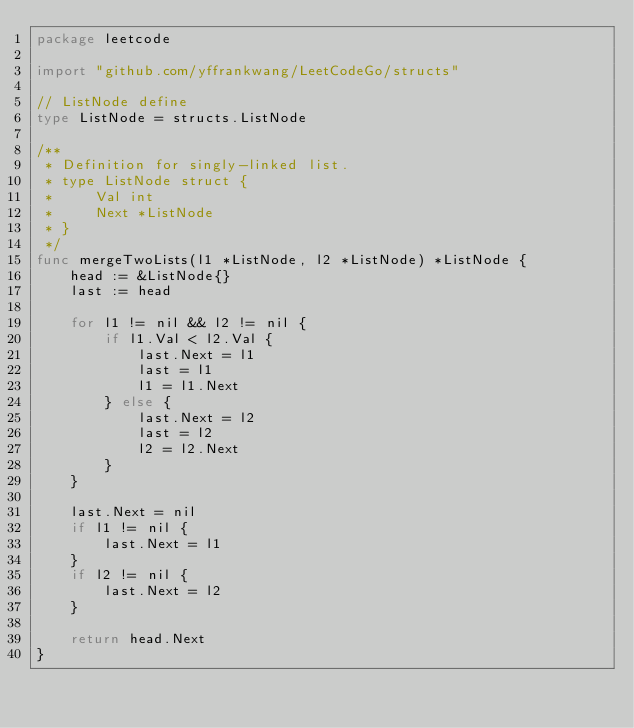<code> <loc_0><loc_0><loc_500><loc_500><_Go_>package leetcode

import "github.com/yffrankwang/LeetCodeGo/structs"

// ListNode define
type ListNode = structs.ListNode

/**
 * Definition for singly-linked list.
 * type ListNode struct {
 *     Val int
 *     Next *ListNode
 * }
 */
func mergeTwoLists(l1 *ListNode, l2 *ListNode) *ListNode {
	head := &ListNode{}
	last := head

	for l1 != nil && l2 != nil {
		if l1.Val < l2.Val {
			last.Next = l1
			last = l1
			l1 = l1.Next
		} else {
			last.Next = l2
			last = l2
			l2 = l2.Next
		}
	}

	last.Next = nil
	if l1 != nil {
		last.Next = l1
	}
	if l2 != nil {
		last.Next = l2
	}

	return head.Next
}
</code> 